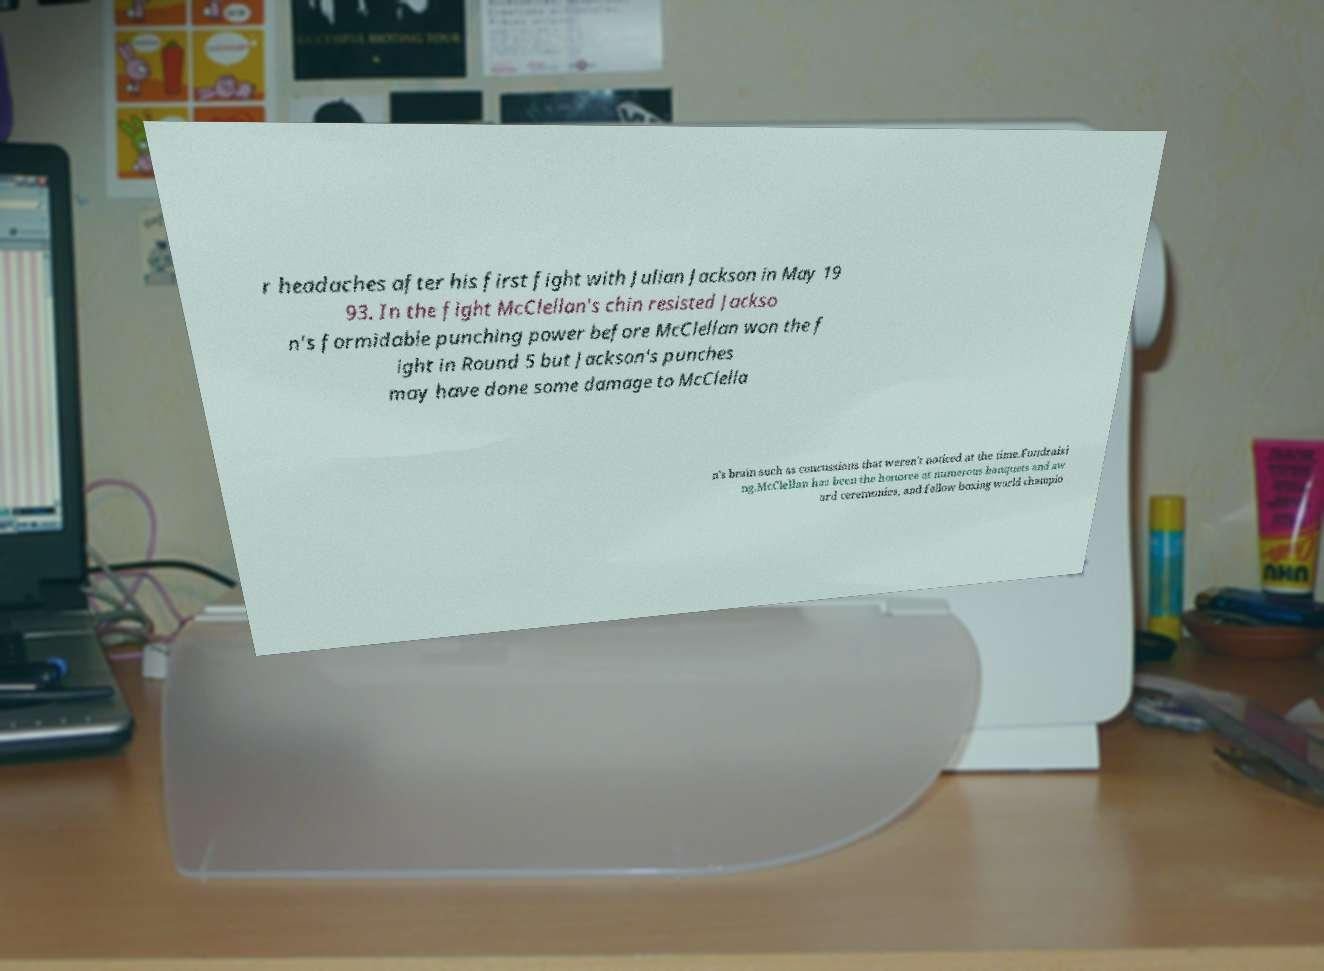Please read and relay the text visible in this image. What does it say? r headaches after his first fight with Julian Jackson in May 19 93. In the fight McClellan's chin resisted Jackso n's formidable punching power before McClellan won the f ight in Round 5 but Jackson's punches may have done some damage to McClella n's brain such as concussions that weren't noticed at the time.Fundraisi ng.McClellan has been the honoree at numerous banquets and aw ard ceremonies, and fellow boxing world champio 